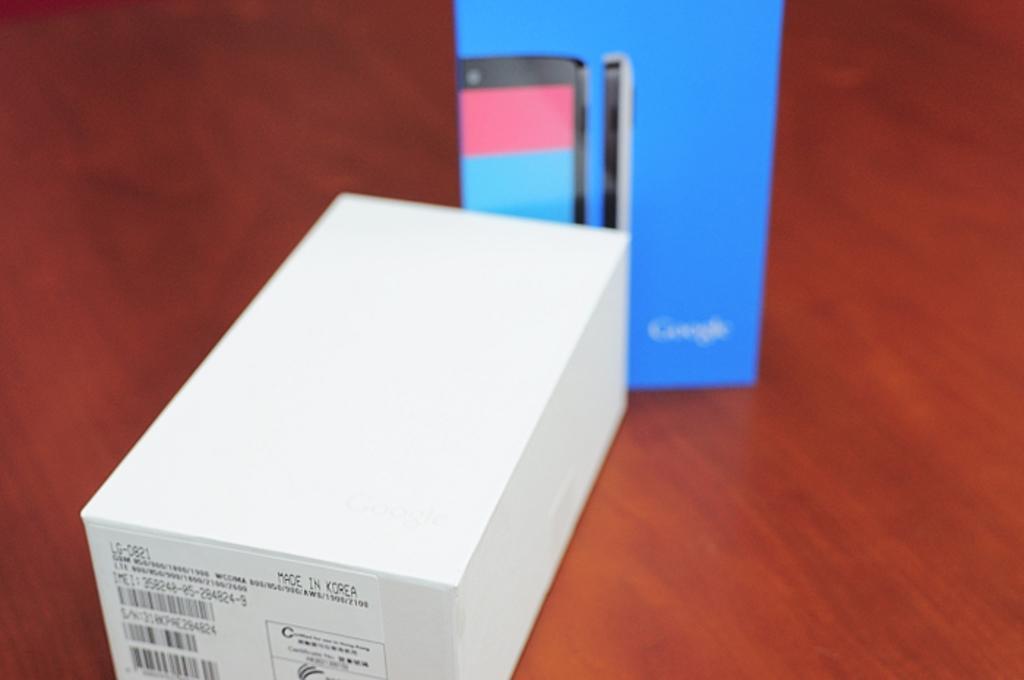How would you summarize this image in a sentence or two? In the picture there are two boxes of a mobile phone kept on a surface. 